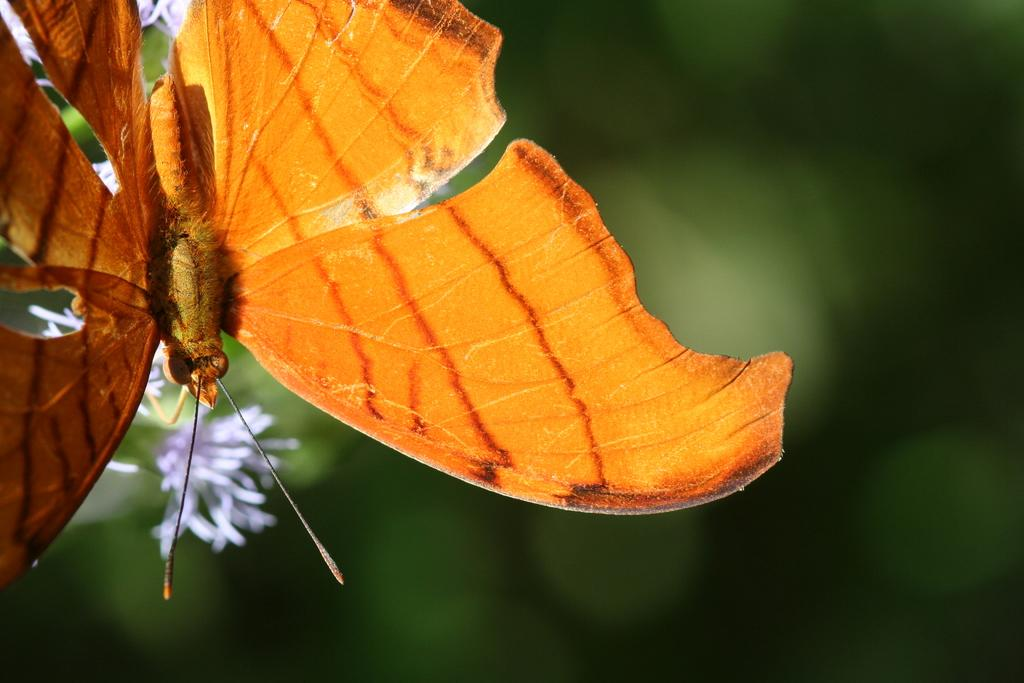What type of animal can be seen in the image? There is a butterfly in the image. What other living organisms are present in the image? There are flowers in the image. Can you describe the background of the image? The background of the image is blurred. What type of oil can be seen dripping from the butterfly's wings in the image? There is no oil present in the image, and the butterfly's wings are not depicted as dripping anything. 